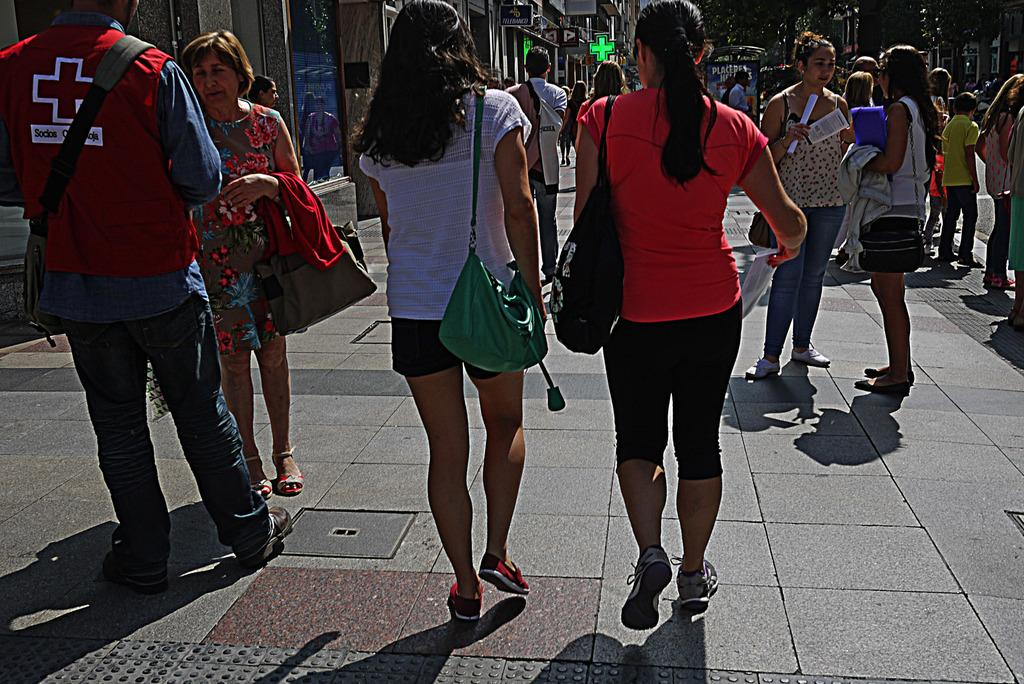What is happening on the road in the image? There are many persons on the road in the image. What can be seen in the background of the image? There are buildings, shops, name boards, and trees visible in the background. What type of wristwatch can be seen on the road in the image? There is no wristwatch visible on the road in the image. Can you describe the bedroom in the image? There is no bedroom present in the image; it features a road with many persons and background elements. 